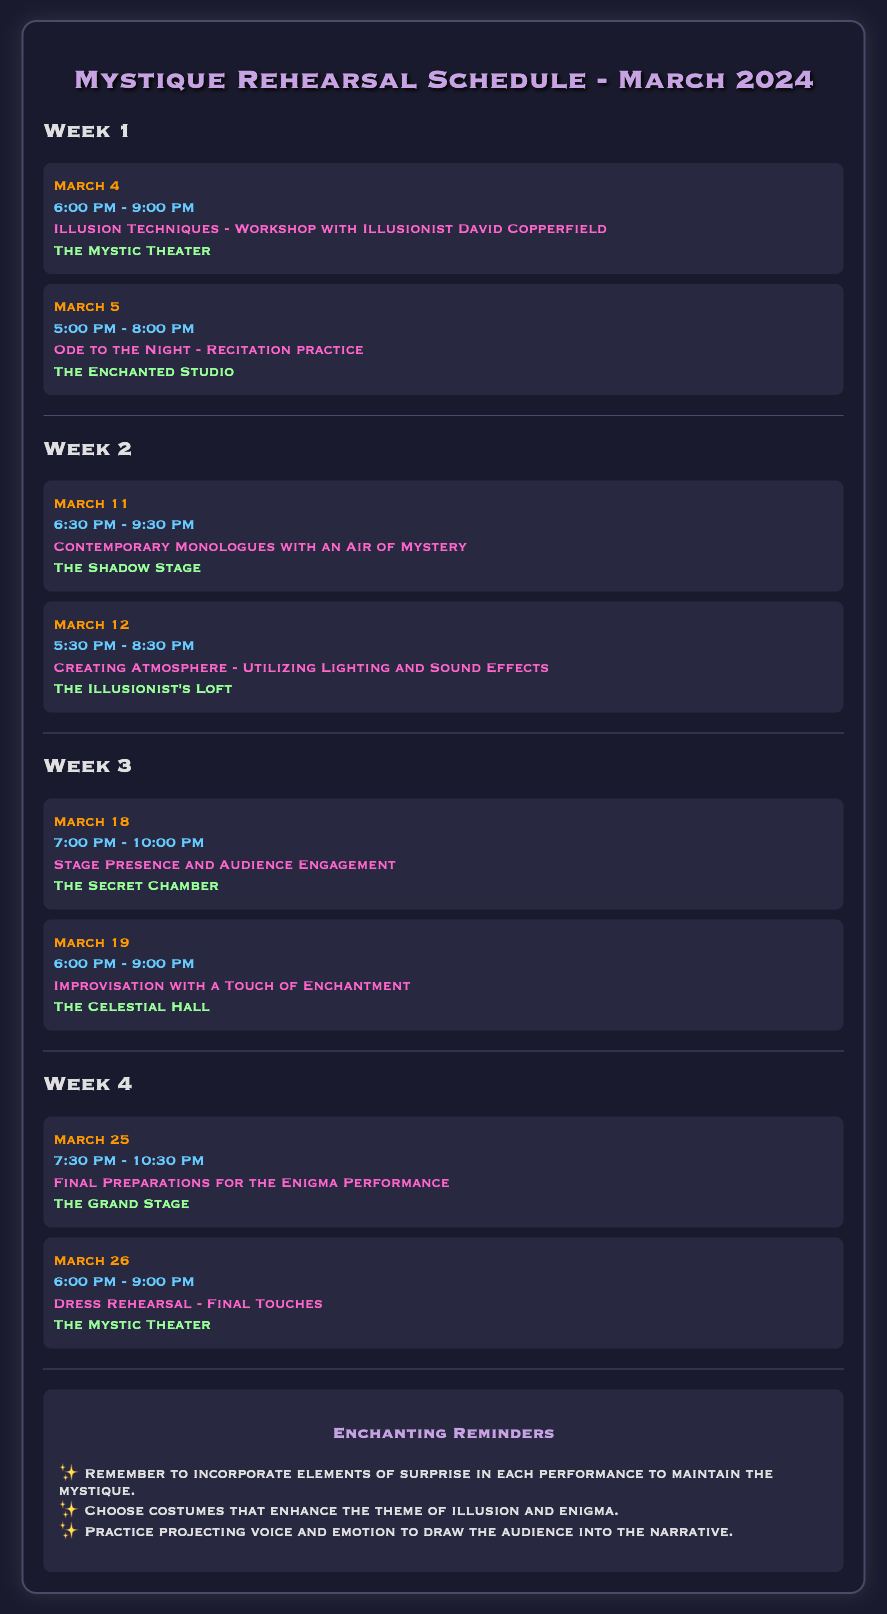what is the date of the first rehearsal? The first rehearsal is scheduled for March 4.
Answer: March 4 what is the time slot for the workshop with David Copperfield? The workshop with David Copperfield is from 6:00 PM to 9:00 PM.
Answer: 6:00 PM - 9:00 PM how many performances are scheduled in Week 2? There are two performances scheduled in Week 2.
Answer: 2 what is the location for the dress rehearsal? The dress rehearsal will take place at The Mystic Theater.
Answer: The Mystic Theater which week has a focus on stage presence? Week 3 has a focus on stage presence and audience engagement.
Answer: Week 3 what is the common theme for the performances in March 2024? The common theme for the performances is mystery and illusion.
Answer: mystery and illusion what are the final preparations scheduled for March 25? The final preparations on March 25 are for the Enigma Performance.
Answer: Enigma Performance which performance occurs after the improvisation session? The dress rehearsal occurs after the improvisation session.
Answer: dress rehearsal who is leading the workshop on March 4? The workshop on March 4 is led by Illusionist David Copperfield.
Answer: David Copperfield 